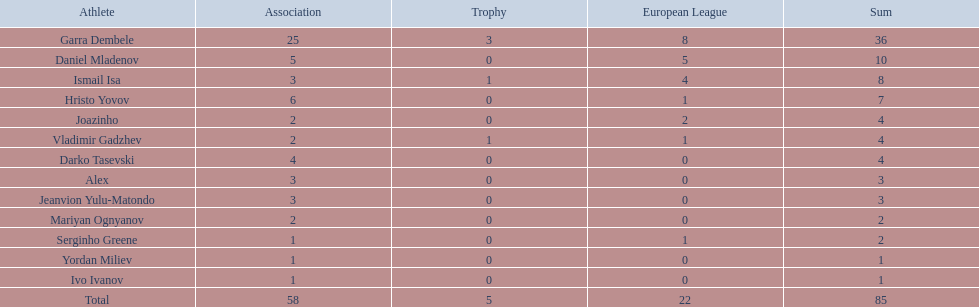How many goals did ismail isa score this season? 8. Could you help me parse every detail presented in this table? {'header': ['Athlete', 'Association', 'Trophy', 'European League', 'Sum'], 'rows': [['Garra Dembele', '25', '3', '8', '36'], ['Daniel Mladenov', '5', '0', '5', '10'], ['Ismail Isa', '3', '1', '4', '8'], ['Hristo Yovov', '6', '0', '1', '7'], ['Joazinho', '2', '0', '2', '4'], ['Vladimir Gadzhev', '2', '1', '1', '4'], ['Darko Tasevski', '4', '0', '0', '4'], ['Alex', '3', '0', '0', '3'], ['Jeanvion Yulu-Matondo', '3', '0', '0', '3'], ['Mariyan Ognyanov', '2', '0', '0', '2'], ['Serginho Greene', '1', '0', '1', '2'], ['Yordan Miliev', '1', '0', '0', '1'], ['Ivo Ivanov', '1', '0', '0', '1'], ['Total', '58', '5', '22', '85']]} 